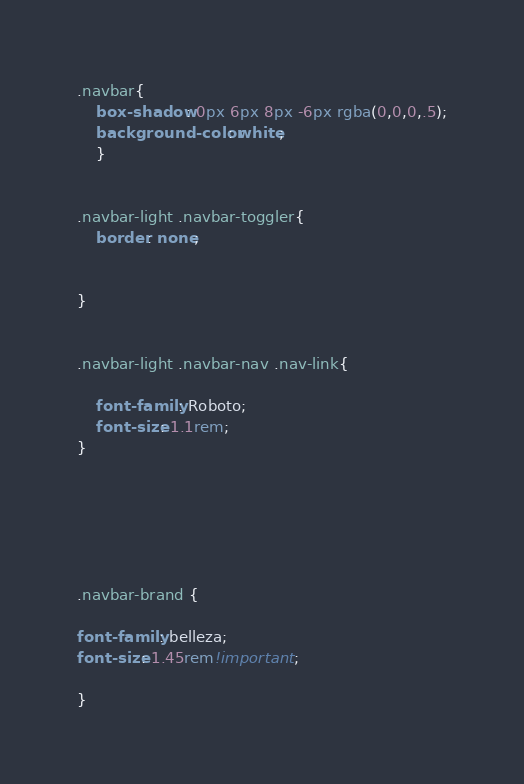Convert code to text. <code><loc_0><loc_0><loc_500><loc_500><_CSS_>.navbar{
    box-shadow: 0px 6px 8px -6px rgba(0,0,0,.5);
    background-color: white;
    }


.navbar-light .navbar-toggler{
    border: none;


}


.navbar-light .navbar-nav .nav-link{

    font-family: Roboto;
    font-size: 1.1rem;
}






.navbar-brand {

font-family: belleza;
font-size: 1.45rem!important;

}

</code> 